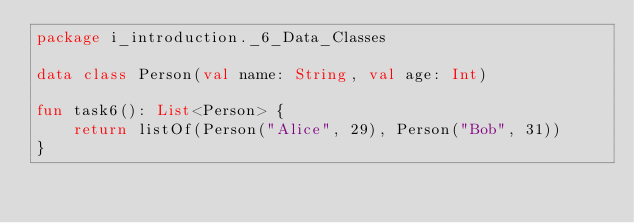<code> <loc_0><loc_0><loc_500><loc_500><_Kotlin_>package i_introduction._6_Data_Classes

data class Person(val name: String, val age: Int)

fun task6(): List<Person> {
    return listOf(Person("Alice", 29), Person("Bob", 31))
}
</code> 